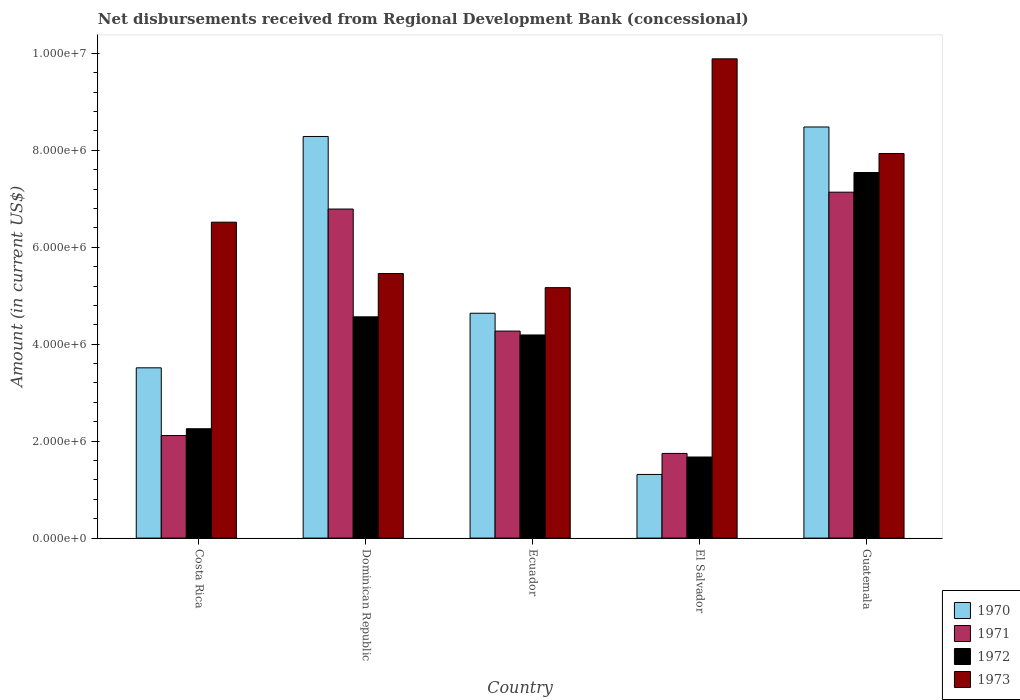Are the number of bars on each tick of the X-axis equal?
Provide a succinct answer. Yes. How many bars are there on the 1st tick from the left?
Make the answer very short. 4. How many bars are there on the 2nd tick from the right?
Your response must be concise. 4. What is the label of the 5th group of bars from the left?
Give a very brief answer. Guatemala. In how many cases, is the number of bars for a given country not equal to the number of legend labels?
Make the answer very short. 0. What is the amount of disbursements received from Regional Development Bank in 1970 in Costa Rica?
Your answer should be very brief. 3.51e+06. Across all countries, what is the maximum amount of disbursements received from Regional Development Bank in 1970?
Give a very brief answer. 8.48e+06. Across all countries, what is the minimum amount of disbursements received from Regional Development Bank in 1973?
Your answer should be very brief. 5.17e+06. In which country was the amount of disbursements received from Regional Development Bank in 1972 maximum?
Your answer should be very brief. Guatemala. In which country was the amount of disbursements received from Regional Development Bank in 1970 minimum?
Offer a very short reply. El Salvador. What is the total amount of disbursements received from Regional Development Bank in 1972 in the graph?
Your response must be concise. 2.02e+07. What is the difference between the amount of disbursements received from Regional Development Bank in 1973 in Costa Rica and that in Dominican Republic?
Make the answer very short. 1.06e+06. What is the difference between the amount of disbursements received from Regional Development Bank in 1972 in Costa Rica and the amount of disbursements received from Regional Development Bank in 1970 in El Salvador?
Your answer should be very brief. 9.43e+05. What is the average amount of disbursements received from Regional Development Bank in 1970 per country?
Keep it short and to the point. 5.25e+06. What is the difference between the amount of disbursements received from Regional Development Bank of/in 1970 and amount of disbursements received from Regional Development Bank of/in 1971 in Ecuador?
Your answer should be compact. 3.68e+05. In how many countries, is the amount of disbursements received from Regional Development Bank in 1971 greater than 3600000 US$?
Provide a succinct answer. 3. What is the ratio of the amount of disbursements received from Regional Development Bank in 1971 in Costa Rica to that in Ecuador?
Your answer should be compact. 0.5. Is the amount of disbursements received from Regional Development Bank in 1972 in Dominican Republic less than that in El Salvador?
Your answer should be compact. No. Is the difference between the amount of disbursements received from Regional Development Bank in 1970 in Ecuador and El Salvador greater than the difference between the amount of disbursements received from Regional Development Bank in 1971 in Ecuador and El Salvador?
Keep it short and to the point. Yes. What is the difference between the highest and the second highest amount of disbursements received from Regional Development Bank in 1971?
Make the answer very short. 2.87e+06. What is the difference between the highest and the lowest amount of disbursements received from Regional Development Bank in 1971?
Make the answer very short. 5.39e+06. Is it the case that in every country, the sum of the amount of disbursements received from Regional Development Bank in 1973 and amount of disbursements received from Regional Development Bank in 1970 is greater than the sum of amount of disbursements received from Regional Development Bank in 1971 and amount of disbursements received from Regional Development Bank in 1972?
Offer a very short reply. Yes. Is it the case that in every country, the sum of the amount of disbursements received from Regional Development Bank in 1971 and amount of disbursements received from Regional Development Bank in 1973 is greater than the amount of disbursements received from Regional Development Bank in 1970?
Provide a succinct answer. Yes. How many bars are there?
Your response must be concise. 20. What is the difference between two consecutive major ticks on the Y-axis?
Your answer should be compact. 2.00e+06. Where does the legend appear in the graph?
Provide a succinct answer. Bottom right. How many legend labels are there?
Make the answer very short. 4. What is the title of the graph?
Make the answer very short. Net disbursements received from Regional Development Bank (concessional). What is the label or title of the Y-axis?
Give a very brief answer. Amount (in current US$). What is the Amount (in current US$) of 1970 in Costa Rica?
Your response must be concise. 3.51e+06. What is the Amount (in current US$) in 1971 in Costa Rica?
Give a very brief answer. 2.12e+06. What is the Amount (in current US$) of 1972 in Costa Rica?
Your response must be concise. 2.26e+06. What is the Amount (in current US$) in 1973 in Costa Rica?
Offer a very short reply. 6.52e+06. What is the Amount (in current US$) in 1970 in Dominican Republic?
Offer a terse response. 8.29e+06. What is the Amount (in current US$) in 1971 in Dominican Republic?
Ensure brevity in your answer.  6.79e+06. What is the Amount (in current US$) in 1972 in Dominican Republic?
Provide a short and direct response. 4.56e+06. What is the Amount (in current US$) of 1973 in Dominican Republic?
Offer a terse response. 5.46e+06. What is the Amount (in current US$) of 1970 in Ecuador?
Give a very brief answer. 4.64e+06. What is the Amount (in current US$) in 1971 in Ecuador?
Your answer should be compact. 4.27e+06. What is the Amount (in current US$) in 1972 in Ecuador?
Give a very brief answer. 4.19e+06. What is the Amount (in current US$) of 1973 in Ecuador?
Your response must be concise. 5.17e+06. What is the Amount (in current US$) in 1970 in El Salvador?
Your answer should be very brief. 1.31e+06. What is the Amount (in current US$) in 1971 in El Salvador?
Provide a short and direct response. 1.75e+06. What is the Amount (in current US$) in 1972 in El Salvador?
Ensure brevity in your answer.  1.67e+06. What is the Amount (in current US$) in 1973 in El Salvador?
Keep it short and to the point. 9.89e+06. What is the Amount (in current US$) of 1970 in Guatemala?
Provide a short and direct response. 8.48e+06. What is the Amount (in current US$) of 1971 in Guatemala?
Your answer should be very brief. 7.14e+06. What is the Amount (in current US$) of 1972 in Guatemala?
Ensure brevity in your answer.  7.54e+06. What is the Amount (in current US$) of 1973 in Guatemala?
Make the answer very short. 7.94e+06. Across all countries, what is the maximum Amount (in current US$) in 1970?
Keep it short and to the point. 8.48e+06. Across all countries, what is the maximum Amount (in current US$) in 1971?
Your response must be concise. 7.14e+06. Across all countries, what is the maximum Amount (in current US$) of 1972?
Give a very brief answer. 7.54e+06. Across all countries, what is the maximum Amount (in current US$) of 1973?
Give a very brief answer. 9.89e+06. Across all countries, what is the minimum Amount (in current US$) of 1970?
Give a very brief answer. 1.31e+06. Across all countries, what is the minimum Amount (in current US$) in 1971?
Ensure brevity in your answer.  1.75e+06. Across all countries, what is the minimum Amount (in current US$) in 1972?
Your response must be concise. 1.67e+06. Across all countries, what is the minimum Amount (in current US$) of 1973?
Keep it short and to the point. 5.17e+06. What is the total Amount (in current US$) in 1970 in the graph?
Your answer should be compact. 2.62e+07. What is the total Amount (in current US$) in 1971 in the graph?
Keep it short and to the point. 2.21e+07. What is the total Amount (in current US$) in 1972 in the graph?
Your answer should be very brief. 2.02e+07. What is the total Amount (in current US$) of 1973 in the graph?
Your response must be concise. 3.50e+07. What is the difference between the Amount (in current US$) of 1970 in Costa Rica and that in Dominican Republic?
Provide a succinct answer. -4.77e+06. What is the difference between the Amount (in current US$) in 1971 in Costa Rica and that in Dominican Republic?
Offer a very short reply. -4.67e+06. What is the difference between the Amount (in current US$) in 1972 in Costa Rica and that in Dominican Republic?
Provide a short and direct response. -2.31e+06. What is the difference between the Amount (in current US$) in 1973 in Costa Rica and that in Dominican Republic?
Give a very brief answer. 1.06e+06. What is the difference between the Amount (in current US$) in 1970 in Costa Rica and that in Ecuador?
Make the answer very short. -1.13e+06. What is the difference between the Amount (in current US$) in 1971 in Costa Rica and that in Ecuador?
Your answer should be compact. -2.16e+06. What is the difference between the Amount (in current US$) in 1972 in Costa Rica and that in Ecuador?
Your response must be concise. -1.94e+06. What is the difference between the Amount (in current US$) of 1973 in Costa Rica and that in Ecuador?
Give a very brief answer. 1.35e+06. What is the difference between the Amount (in current US$) in 1970 in Costa Rica and that in El Salvador?
Offer a terse response. 2.20e+06. What is the difference between the Amount (in current US$) of 1971 in Costa Rica and that in El Salvador?
Ensure brevity in your answer.  3.69e+05. What is the difference between the Amount (in current US$) of 1972 in Costa Rica and that in El Salvador?
Make the answer very short. 5.83e+05. What is the difference between the Amount (in current US$) of 1973 in Costa Rica and that in El Salvador?
Keep it short and to the point. -3.37e+06. What is the difference between the Amount (in current US$) of 1970 in Costa Rica and that in Guatemala?
Your response must be concise. -4.97e+06. What is the difference between the Amount (in current US$) in 1971 in Costa Rica and that in Guatemala?
Provide a short and direct response. -5.02e+06. What is the difference between the Amount (in current US$) of 1972 in Costa Rica and that in Guatemala?
Give a very brief answer. -5.29e+06. What is the difference between the Amount (in current US$) in 1973 in Costa Rica and that in Guatemala?
Offer a very short reply. -1.42e+06. What is the difference between the Amount (in current US$) in 1970 in Dominican Republic and that in Ecuador?
Keep it short and to the point. 3.65e+06. What is the difference between the Amount (in current US$) of 1971 in Dominican Republic and that in Ecuador?
Ensure brevity in your answer.  2.52e+06. What is the difference between the Amount (in current US$) of 1972 in Dominican Republic and that in Ecuador?
Make the answer very short. 3.74e+05. What is the difference between the Amount (in current US$) in 1973 in Dominican Republic and that in Ecuador?
Provide a succinct answer. 2.92e+05. What is the difference between the Amount (in current US$) of 1970 in Dominican Republic and that in El Salvador?
Your response must be concise. 6.97e+06. What is the difference between the Amount (in current US$) in 1971 in Dominican Republic and that in El Salvador?
Ensure brevity in your answer.  5.04e+06. What is the difference between the Amount (in current US$) in 1972 in Dominican Republic and that in El Salvador?
Your answer should be very brief. 2.89e+06. What is the difference between the Amount (in current US$) in 1973 in Dominican Republic and that in El Salvador?
Offer a very short reply. -4.43e+06. What is the difference between the Amount (in current US$) of 1970 in Dominican Republic and that in Guatemala?
Make the answer very short. -1.96e+05. What is the difference between the Amount (in current US$) in 1971 in Dominican Republic and that in Guatemala?
Offer a terse response. -3.48e+05. What is the difference between the Amount (in current US$) of 1972 in Dominican Republic and that in Guatemala?
Offer a terse response. -2.98e+06. What is the difference between the Amount (in current US$) of 1973 in Dominican Republic and that in Guatemala?
Offer a terse response. -2.48e+06. What is the difference between the Amount (in current US$) in 1970 in Ecuador and that in El Salvador?
Offer a very short reply. 3.33e+06. What is the difference between the Amount (in current US$) in 1971 in Ecuador and that in El Salvador?
Offer a terse response. 2.52e+06. What is the difference between the Amount (in current US$) of 1972 in Ecuador and that in El Salvador?
Make the answer very short. 2.52e+06. What is the difference between the Amount (in current US$) in 1973 in Ecuador and that in El Salvador?
Your answer should be compact. -4.72e+06. What is the difference between the Amount (in current US$) in 1970 in Ecuador and that in Guatemala?
Keep it short and to the point. -3.84e+06. What is the difference between the Amount (in current US$) of 1971 in Ecuador and that in Guatemala?
Provide a short and direct response. -2.87e+06. What is the difference between the Amount (in current US$) of 1972 in Ecuador and that in Guatemala?
Provide a short and direct response. -3.35e+06. What is the difference between the Amount (in current US$) of 1973 in Ecuador and that in Guatemala?
Offer a terse response. -2.77e+06. What is the difference between the Amount (in current US$) of 1970 in El Salvador and that in Guatemala?
Offer a very short reply. -7.17e+06. What is the difference between the Amount (in current US$) of 1971 in El Salvador and that in Guatemala?
Your answer should be compact. -5.39e+06. What is the difference between the Amount (in current US$) in 1972 in El Salvador and that in Guatemala?
Provide a succinct answer. -5.87e+06. What is the difference between the Amount (in current US$) of 1973 in El Salvador and that in Guatemala?
Your answer should be compact. 1.95e+06. What is the difference between the Amount (in current US$) of 1970 in Costa Rica and the Amount (in current US$) of 1971 in Dominican Republic?
Provide a short and direct response. -3.28e+06. What is the difference between the Amount (in current US$) of 1970 in Costa Rica and the Amount (in current US$) of 1972 in Dominican Republic?
Make the answer very short. -1.05e+06. What is the difference between the Amount (in current US$) in 1970 in Costa Rica and the Amount (in current US$) in 1973 in Dominican Republic?
Offer a very short reply. -1.95e+06. What is the difference between the Amount (in current US$) of 1971 in Costa Rica and the Amount (in current US$) of 1972 in Dominican Republic?
Give a very brief answer. -2.45e+06. What is the difference between the Amount (in current US$) in 1971 in Costa Rica and the Amount (in current US$) in 1973 in Dominican Republic?
Keep it short and to the point. -3.34e+06. What is the difference between the Amount (in current US$) in 1972 in Costa Rica and the Amount (in current US$) in 1973 in Dominican Republic?
Your answer should be compact. -3.20e+06. What is the difference between the Amount (in current US$) of 1970 in Costa Rica and the Amount (in current US$) of 1971 in Ecuador?
Your answer should be compact. -7.58e+05. What is the difference between the Amount (in current US$) of 1970 in Costa Rica and the Amount (in current US$) of 1972 in Ecuador?
Provide a short and direct response. -6.78e+05. What is the difference between the Amount (in current US$) of 1970 in Costa Rica and the Amount (in current US$) of 1973 in Ecuador?
Offer a terse response. -1.65e+06. What is the difference between the Amount (in current US$) in 1971 in Costa Rica and the Amount (in current US$) in 1972 in Ecuador?
Offer a terse response. -2.08e+06. What is the difference between the Amount (in current US$) in 1971 in Costa Rica and the Amount (in current US$) in 1973 in Ecuador?
Your answer should be compact. -3.05e+06. What is the difference between the Amount (in current US$) in 1972 in Costa Rica and the Amount (in current US$) in 1973 in Ecuador?
Provide a short and direct response. -2.91e+06. What is the difference between the Amount (in current US$) of 1970 in Costa Rica and the Amount (in current US$) of 1971 in El Salvador?
Your answer should be compact. 1.77e+06. What is the difference between the Amount (in current US$) of 1970 in Costa Rica and the Amount (in current US$) of 1972 in El Salvador?
Make the answer very short. 1.84e+06. What is the difference between the Amount (in current US$) in 1970 in Costa Rica and the Amount (in current US$) in 1973 in El Salvador?
Your answer should be very brief. -6.38e+06. What is the difference between the Amount (in current US$) in 1971 in Costa Rica and the Amount (in current US$) in 1972 in El Salvador?
Offer a terse response. 4.43e+05. What is the difference between the Amount (in current US$) of 1971 in Costa Rica and the Amount (in current US$) of 1973 in El Salvador?
Make the answer very short. -7.77e+06. What is the difference between the Amount (in current US$) in 1972 in Costa Rica and the Amount (in current US$) in 1973 in El Salvador?
Provide a succinct answer. -7.63e+06. What is the difference between the Amount (in current US$) of 1970 in Costa Rica and the Amount (in current US$) of 1971 in Guatemala?
Your response must be concise. -3.62e+06. What is the difference between the Amount (in current US$) of 1970 in Costa Rica and the Amount (in current US$) of 1972 in Guatemala?
Your answer should be compact. -4.03e+06. What is the difference between the Amount (in current US$) in 1970 in Costa Rica and the Amount (in current US$) in 1973 in Guatemala?
Provide a short and direct response. -4.42e+06. What is the difference between the Amount (in current US$) in 1971 in Costa Rica and the Amount (in current US$) in 1972 in Guatemala?
Offer a very short reply. -5.43e+06. What is the difference between the Amount (in current US$) in 1971 in Costa Rica and the Amount (in current US$) in 1973 in Guatemala?
Offer a very short reply. -5.82e+06. What is the difference between the Amount (in current US$) in 1972 in Costa Rica and the Amount (in current US$) in 1973 in Guatemala?
Give a very brief answer. -5.68e+06. What is the difference between the Amount (in current US$) of 1970 in Dominican Republic and the Amount (in current US$) of 1971 in Ecuador?
Provide a short and direct response. 4.02e+06. What is the difference between the Amount (in current US$) of 1970 in Dominican Republic and the Amount (in current US$) of 1972 in Ecuador?
Provide a short and direct response. 4.10e+06. What is the difference between the Amount (in current US$) in 1970 in Dominican Republic and the Amount (in current US$) in 1973 in Ecuador?
Provide a succinct answer. 3.12e+06. What is the difference between the Amount (in current US$) in 1971 in Dominican Republic and the Amount (in current US$) in 1972 in Ecuador?
Provide a short and direct response. 2.60e+06. What is the difference between the Amount (in current US$) in 1971 in Dominican Republic and the Amount (in current US$) in 1973 in Ecuador?
Your answer should be very brief. 1.62e+06. What is the difference between the Amount (in current US$) of 1972 in Dominican Republic and the Amount (in current US$) of 1973 in Ecuador?
Provide a succinct answer. -6.02e+05. What is the difference between the Amount (in current US$) in 1970 in Dominican Republic and the Amount (in current US$) in 1971 in El Salvador?
Ensure brevity in your answer.  6.54e+06. What is the difference between the Amount (in current US$) in 1970 in Dominican Republic and the Amount (in current US$) in 1972 in El Salvador?
Provide a succinct answer. 6.61e+06. What is the difference between the Amount (in current US$) of 1970 in Dominican Republic and the Amount (in current US$) of 1973 in El Salvador?
Provide a succinct answer. -1.60e+06. What is the difference between the Amount (in current US$) in 1971 in Dominican Republic and the Amount (in current US$) in 1972 in El Salvador?
Provide a short and direct response. 5.12e+06. What is the difference between the Amount (in current US$) in 1971 in Dominican Republic and the Amount (in current US$) in 1973 in El Salvador?
Provide a short and direct response. -3.10e+06. What is the difference between the Amount (in current US$) in 1972 in Dominican Republic and the Amount (in current US$) in 1973 in El Salvador?
Your response must be concise. -5.32e+06. What is the difference between the Amount (in current US$) in 1970 in Dominican Republic and the Amount (in current US$) in 1971 in Guatemala?
Offer a very short reply. 1.15e+06. What is the difference between the Amount (in current US$) in 1970 in Dominican Republic and the Amount (in current US$) in 1972 in Guatemala?
Your answer should be compact. 7.43e+05. What is the difference between the Amount (in current US$) of 1970 in Dominican Republic and the Amount (in current US$) of 1973 in Guatemala?
Your response must be concise. 3.51e+05. What is the difference between the Amount (in current US$) in 1971 in Dominican Republic and the Amount (in current US$) in 1972 in Guatemala?
Your answer should be compact. -7.54e+05. What is the difference between the Amount (in current US$) in 1971 in Dominican Republic and the Amount (in current US$) in 1973 in Guatemala?
Provide a short and direct response. -1.15e+06. What is the difference between the Amount (in current US$) of 1972 in Dominican Republic and the Amount (in current US$) of 1973 in Guatemala?
Your response must be concise. -3.37e+06. What is the difference between the Amount (in current US$) of 1970 in Ecuador and the Amount (in current US$) of 1971 in El Salvador?
Your response must be concise. 2.89e+06. What is the difference between the Amount (in current US$) of 1970 in Ecuador and the Amount (in current US$) of 1972 in El Salvador?
Your answer should be very brief. 2.97e+06. What is the difference between the Amount (in current US$) in 1970 in Ecuador and the Amount (in current US$) in 1973 in El Salvador?
Your response must be concise. -5.25e+06. What is the difference between the Amount (in current US$) in 1971 in Ecuador and the Amount (in current US$) in 1972 in El Salvador?
Give a very brief answer. 2.60e+06. What is the difference between the Amount (in current US$) in 1971 in Ecuador and the Amount (in current US$) in 1973 in El Salvador?
Provide a short and direct response. -5.62e+06. What is the difference between the Amount (in current US$) of 1972 in Ecuador and the Amount (in current US$) of 1973 in El Salvador?
Ensure brevity in your answer.  -5.70e+06. What is the difference between the Amount (in current US$) of 1970 in Ecuador and the Amount (in current US$) of 1971 in Guatemala?
Your response must be concise. -2.50e+06. What is the difference between the Amount (in current US$) in 1970 in Ecuador and the Amount (in current US$) in 1972 in Guatemala?
Give a very brief answer. -2.90e+06. What is the difference between the Amount (in current US$) in 1970 in Ecuador and the Amount (in current US$) in 1973 in Guatemala?
Your response must be concise. -3.30e+06. What is the difference between the Amount (in current US$) of 1971 in Ecuador and the Amount (in current US$) of 1972 in Guatemala?
Keep it short and to the point. -3.27e+06. What is the difference between the Amount (in current US$) of 1971 in Ecuador and the Amount (in current US$) of 1973 in Guatemala?
Ensure brevity in your answer.  -3.66e+06. What is the difference between the Amount (in current US$) of 1972 in Ecuador and the Amount (in current US$) of 1973 in Guatemala?
Make the answer very short. -3.74e+06. What is the difference between the Amount (in current US$) of 1970 in El Salvador and the Amount (in current US$) of 1971 in Guatemala?
Your answer should be compact. -5.82e+06. What is the difference between the Amount (in current US$) of 1970 in El Salvador and the Amount (in current US$) of 1972 in Guatemala?
Your answer should be very brief. -6.23e+06. What is the difference between the Amount (in current US$) in 1970 in El Salvador and the Amount (in current US$) in 1973 in Guatemala?
Provide a succinct answer. -6.62e+06. What is the difference between the Amount (in current US$) in 1971 in El Salvador and the Amount (in current US$) in 1972 in Guatemala?
Give a very brief answer. -5.80e+06. What is the difference between the Amount (in current US$) in 1971 in El Salvador and the Amount (in current US$) in 1973 in Guatemala?
Keep it short and to the point. -6.19e+06. What is the difference between the Amount (in current US$) of 1972 in El Salvador and the Amount (in current US$) of 1973 in Guatemala?
Offer a terse response. -6.26e+06. What is the average Amount (in current US$) of 1970 per country?
Offer a very short reply. 5.25e+06. What is the average Amount (in current US$) of 1971 per country?
Provide a short and direct response. 4.41e+06. What is the average Amount (in current US$) of 1972 per country?
Your answer should be very brief. 4.05e+06. What is the average Amount (in current US$) of 1973 per country?
Your answer should be compact. 6.99e+06. What is the difference between the Amount (in current US$) of 1970 and Amount (in current US$) of 1971 in Costa Rica?
Give a very brief answer. 1.40e+06. What is the difference between the Amount (in current US$) of 1970 and Amount (in current US$) of 1972 in Costa Rica?
Offer a terse response. 1.26e+06. What is the difference between the Amount (in current US$) of 1970 and Amount (in current US$) of 1973 in Costa Rica?
Ensure brevity in your answer.  -3.00e+06. What is the difference between the Amount (in current US$) in 1971 and Amount (in current US$) in 1973 in Costa Rica?
Give a very brief answer. -4.40e+06. What is the difference between the Amount (in current US$) in 1972 and Amount (in current US$) in 1973 in Costa Rica?
Your answer should be compact. -4.26e+06. What is the difference between the Amount (in current US$) of 1970 and Amount (in current US$) of 1971 in Dominican Republic?
Your answer should be compact. 1.50e+06. What is the difference between the Amount (in current US$) of 1970 and Amount (in current US$) of 1972 in Dominican Republic?
Your response must be concise. 3.72e+06. What is the difference between the Amount (in current US$) of 1970 and Amount (in current US$) of 1973 in Dominican Republic?
Your response must be concise. 2.83e+06. What is the difference between the Amount (in current US$) in 1971 and Amount (in current US$) in 1972 in Dominican Republic?
Give a very brief answer. 2.22e+06. What is the difference between the Amount (in current US$) of 1971 and Amount (in current US$) of 1973 in Dominican Republic?
Your answer should be very brief. 1.33e+06. What is the difference between the Amount (in current US$) of 1972 and Amount (in current US$) of 1973 in Dominican Republic?
Your answer should be compact. -8.94e+05. What is the difference between the Amount (in current US$) in 1970 and Amount (in current US$) in 1971 in Ecuador?
Your response must be concise. 3.68e+05. What is the difference between the Amount (in current US$) of 1970 and Amount (in current US$) of 1972 in Ecuador?
Your answer should be very brief. 4.48e+05. What is the difference between the Amount (in current US$) in 1970 and Amount (in current US$) in 1973 in Ecuador?
Offer a very short reply. -5.28e+05. What is the difference between the Amount (in current US$) in 1971 and Amount (in current US$) in 1973 in Ecuador?
Your answer should be very brief. -8.96e+05. What is the difference between the Amount (in current US$) of 1972 and Amount (in current US$) of 1973 in Ecuador?
Provide a short and direct response. -9.76e+05. What is the difference between the Amount (in current US$) in 1970 and Amount (in current US$) in 1971 in El Salvador?
Offer a terse response. -4.34e+05. What is the difference between the Amount (in current US$) in 1970 and Amount (in current US$) in 1972 in El Salvador?
Your answer should be very brief. -3.60e+05. What is the difference between the Amount (in current US$) of 1970 and Amount (in current US$) of 1973 in El Salvador?
Offer a very short reply. -8.58e+06. What is the difference between the Amount (in current US$) of 1971 and Amount (in current US$) of 1972 in El Salvador?
Your response must be concise. 7.40e+04. What is the difference between the Amount (in current US$) of 1971 and Amount (in current US$) of 1973 in El Salvador?
Keep it short and to the point. -8.14e+06. What is the difference between the Amount (in current US$) in 1972 and Amount (in current US$) in 1973 in El Salvador?
Your response must be concise. -8.22e+06. What is the difference between the Amount (in current US$) in 1970 and Amount (in current US$) in 1971 in Guatemala?
Ensure brevity in your answer.  1.34e+06. What is the difference between the Amount (in current US$) of 1970 and Amount (in current US$) of 1972 in Guatemala?
Your answer should be compact. 9.39e+05. What is the difference between the Amount (in current US$) in 1970 and Amount (in current US$) in 1973 in Guatemala?
Your answer should be very brief. 5.47e+05. What is the difference between the Amount (in current US$) of 1971 and Amount (in current US$) of 1972 in Guatemala?
Offer a very short reply. -4.06e+05. What is the difference between the Amount (in current US$) of 1971 and Amount (in current US$) of 1973 in Guatemala?
Ensure brevity in your answer.  -7.98e+05. What is the difference between the Amount (in current US$) in 1972 and Amount (in current US$) in 1973 in Guatemala?
Make the answer very short. -3.92e+05. What is the ratio of the Amount (in current US$) in 1970 in Costa Rica to that in Dominican Republic?
Keep it short and to the point. 0.42. What is the ratio of the Amount (in current US$) of 1971 in Costa Rica to that in Dominican Republic?
Make the answer very short. 0.31. What is the ratio of the Amount (in current US$) of 1972 in Costa Rica to that in Dominican Republic?
Keep it short and to the point. 0.49. What is the ratio of the Amount (in current US$) of 1973 in Costa Rica to that in Dominican Republic?
Offer a very short reply. 1.19. What is the ratio of the Amount (in current US$) in 1970 in Costa Rica to that in Ecuador?
Offer a terse response. 0.76. What is the ratio of the Amount (in current US$) in 1971 in Costa Rica to that in Ecuador?
Offer a terse response. 0.5. What is the ratio of the Amount (in current US$) in 1972 in Costa Rica to that in Ecuador?
Offer a terse response. 0.54. What is the ratio of the Amount (in current US$) of 1973 in Costa Rica to that in Ecuador?
Ensure brevity in your answer.  1.26. What is the ratio of the Amount (in current US$) in 1970 in Costa Rica to that in El Salvador?
Give a very brief answer. 2.68. What is the ratio of the Amount (in current US$) in 1971 in Costa Rica to that in El Salvador?
Provide a short and direct response. 1.21. What is the ratio of the Amount (in current US$) in 1972 in Costa Rica to that in El Salvador?
Ensure brevity in your answer.  1.35. What is the ratio of the Amount (in current US$) in 1973 in Costa Rica to that in El Salvador?
Offer a terse response. 0.66. What is the ratio of the Amount (in current US$) of 1970 in Costa Rica to that in Guatemala?
Ensure brevity in your answer.  0.41. What is the ratio of the Amount (in current US$) in 1971 in Costa Rica to that in Guatemala?
Ensure brevity in your answer.  0.3. What is the ratio of the Amount (in current US$) in 1972 in Costa Rica to that in Guatemala?
Offer a very short reply. 0.3. What is the ratio of the Amount (in current US$) of 1973 in Costa Rica to that in Guatemala?
Give a very brief answer. 0.82. What is the ratio of the Amount (in current US$) of 1970 in Dominican Republic to that in Ecuador?
Ensure brevity in your answer.  1.79. What is the ratio of the Amount (in current US$) in 1971 in Dominican Republic to that in Ecuador?
Provide a succinct answer. 1.59. What is the ratio of the Amount (in current US$) in 1972 in Dominican Republic to that in Ecuador?
Offer a very short reply. 1.09. What is the ratio of the Amount (in current US$) of 1973 in Dominican Republic to that in Ecuador?
Your response must be concise. 1.06. What is the ratio of the Amount (in current US$) of 1970 in Dominican Republic to that in El Salvador?
Your answer should be compact. 6.31. What is the ratio of the Amount (in current US$) of 1971 in Dominican Republic to that in El Salvador?
Give a very brief answer. 3.89. What is the ratio of the Amount (in current US$) in 1972 in Dominican Republic to that in El Salvador?
Provide a short and direct response. 2.73. What is the ratio of the Amount (in current US$) in 1973 in Dominican Republic to that in El Salvador?
Provide a succinct answer. 0.55. What is the ratio of the Amount (in current US$) of 1970 in Dominican Republic to that in Guatemala?
Offer a terse response. 0.98. What is the ratio of the Amount (in current US$) in 1971 in Dominican Republic to that in Guatemala?
Provide a succinct answer. 0.95. What is the ratio of the Amount (in current US$) of 1972 in Dominican Republic to that in Guatemala?
Your response must be concise. 0.61. What is the ratio of the Amount (in current US$) in 1973 in Dominican Republic to that in Guatemala?
Ensure brevity in your answer.  0.69. What is the ratio of the Amount (in current US$) in 1970 in Ecuador to that in El Salvador?
Your answer should be very brief. 3.53. What is the ratio of the Amount (in current US$) of 1971 in Ecuador to that in El Salvador?
Offer a terse response. 2.44. What is the ratio of the Amount (in current US$) in 1972 in Ecuador to that in El Salvador?
Your answer should be very brief. 2.51. What is the ratio of the Amount (in current US$) of 1973 in Ecuador to that in El Salvador?
Give a very brief answer. 0.52. What is the ratio of the Amount (in current US$) of 1970 in Ecuador to that in Guatemala?
Provide a succinct answer. 0.55. What is the ratio of the Amount (in current US$) of 1971 in Ecuador to that in Guatemala?
Make the answer very short. 0.6. What is the ratio of the Amount (in current US$) of 1972 in Ecuador to that in Guatemala?
Provide a short and direct response. 0.56. What is the ratio of the Amount (in current US$) in 1973 in Ecuador to that in Guatemala?
Offer a terse response. 0.65. What is the ratio of the Amount (in current US$) in 1970 in El Salvador to that in Guatemala?
Offer a very short reply. 0.15. What is the ratio of the Amount (in current US$) in 1971 in El Salvador to that in Guatemala?
Keep it short and to the point. 0.24. What is the ratio of the Amount (in current US$) of 1972 in El Salvador to that in Guatemala?
Give a very brief answer. 0.22. What is the ratio of the Amount (in current US$) of 1973 in El Salvador to that in Guatemala?
Make the answer very short. 1.25. What is the difference between the highest and the second highest Amount (in current US$) of 1970?
Your answer should be very brief. 1.96e+05. What is the difference between the highest and the second highest Amount (in current US$) in 1971?
Offer a very short reply. 3.48e+05. What is the difference between the highest and the second highest Amount (in current US$) in 1972?
Offer a terse response. 2.98e+06. What is the difference between the highest and the second highest Amount (in current US$) in 1973?
Your response must be concise. 1.95e+06. What is the difference between the highest and the lowest Amount (in current US$) in 1970?
Provide a short and direct response. 7.17e+06. What is the difference between the highest and the lowest Amount (in current US$) of 1971?
Your response must be concise. 5.39e+06. What is the difference between the highest and the lowest Amount (in current US$) of 1972?
Keep it short and to the point. 5.87e+06. What is the difference between the highest and the lowest Amount (in current US$) in 1973?
Offer a terse response. 4.72e+06. 